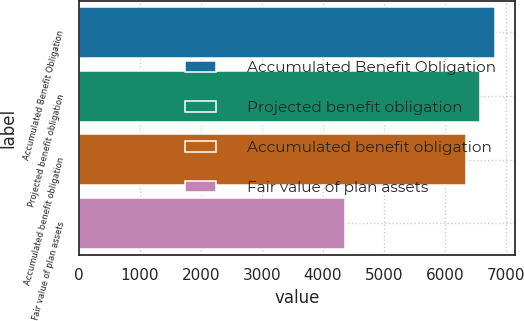Convert chart. <chart><loc_0><loc_0><loc_500><loc_500><bar_chart><fcel>Accumulated Benefit Obligation<fcel>Projected benefit obligation<fcel>Accumulated benefit obligation<fcel>Fair value of plan assets<nl><fcel>6819<fcel>6585.5<fcel>6352<fcel>4360<nl></chart> 